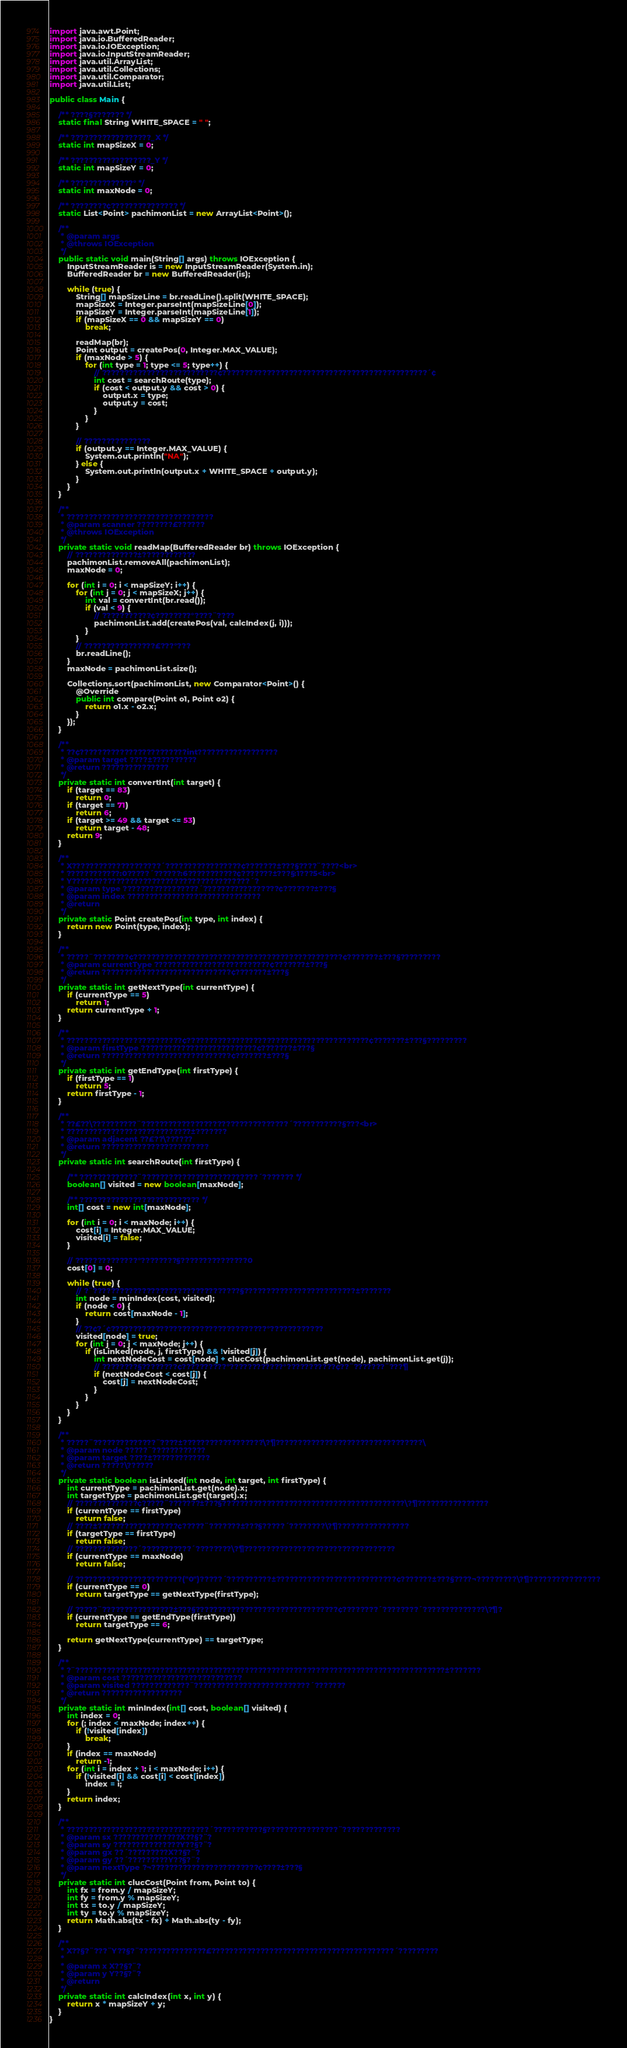Convert code to text. <code><loc_0><loc_0><loc_500><loc_500><_Java_>import java.awt.Point;
import java.io.BufferedReader;
import java.io.IOException;
import java.io.InputStreamReader;
import java.util.ArrayList;
import java.util.Collections;
import java.util.Comparator;
import java.util.List;

public class Main {

	/** ????§??????? */
	static final String WHITE_SPACE = " ";

	/** ??????????????????_X */
	static int mapSizeX = 0;

	/** ??????????????????_Y */
	static int mapSizeY = 0;

	/** ??????????????° */
	static int maxNode = 0;

	/** ????????¢??????????????? */
	static List<Point> pachimonList = new ArrayList<Point>();

	/**
	 * @param args
	 * @throws IOException
	 */
	public static void main(String[] args) throws IOException {
		InputStreamReader is = new InputStreamReader(System.in);
		BufferedReader br = new BufferedReader(is);

		while (true) {
			String[] mapSizeLine = br.readLine().split(WHITE_SPACE);
			mapSizeX = Integer.parseInt(mapSizeLine[0]);
			mapSizeY = Integer.parseInt(mapSizeLine[1]);
			if (mapSizeX == 0 && mapSizeY == 0)
				break;

			readMap(br);
			Point output = createPos(0, Integer.MAX_VALUE);
			if (maxNode > 5) {
				for (int type = 1; type <= 5; type++) {
					// ??????????????????????????¢??????????????????????????????????????????????´¢
					int cost = searchRoute(type);
					if (cost < output.y && cost > 0) {
						output.x = type;
						output.y = cost;
					}
				}
			}

			// ???????????????
			if (output.y == Integer.MAX_VALUE) {
				System.out.println("NA");
			} else {
				System.out.println(output.x + WHITE_SPACE + output.y);
			}
		}
	}

	/**
	 * ?????????????????????????????????
	 * @param scanner ????????£??????
	 * @throws IOException
	 */
	private static void readMap(BufferedReader br) throws IOException {
		// ??????????????±????????????
		pachimonList.removeAll(pachimonList);
		maxNode = 0;

		for (int i = 0; i < mapSizeY; i++) {
			for (int j = 0; j < mapSizeX; j++) {
				int val = convertInt(br.read());
				if (val < 9) {
					// ???????????¢????????°????¨????
					pachimonList.add(createPos(val, calcIndex(j, i)));
				}
			}
			// ????????????????£???°???
			br.readLine();
		}
		maxNode = pachimonList.size();

		Collections.sort(pachimonList, new Comparator<Point>() {
			@Override
			public int compare(Point o1, Point o2) {
				return o1.x - o2.x;
			}
		});
	}

	/**
	 * ??¢????????????????????????int??????????????????
	 * @param target ????±??????????
	 * @return ???????????????
	 */
	private static int convertInt(int target) {
		if (target == 83)
			return 0;
		if (target == 71)
			return 6;
		if (target >= 49 && target <= 53)
			return target - 48;
		return 9;
	}

	/**
	 * X????????????????????´?????????????????¢???????±???§????¨????<br>
	 * ????????????:0?????´??????:6???????????¢???????±???§:1???5<br>
	 * Y????????????????????????????????????????´?
	 * @param type ?????????????????´?????????????????¢???????±???§
	 * @param index ??????????????????????????????
	 * @return
	 */
	private static Point createPos(int type, int index) {
		return new Point(type, index);
	}

	/**
	 * ?????¨????????¢???????????????????????????????????????????????¢???????±???§?????????
	 * @param currentType ??????????????????????????¢???????±???§
	 * @return ?????????????????????????????¢???????±???§
	 */
	private static int getNextType(int currentType) {
		if (currentType == 5)
			return 1;
		return currentType + 1;
	}

	/**
	 * ??????????????????????????¢?????????????????????????????????????????¢???????±???§?????????
	 * @param firstType ??????????????????????????¢???????±???§
	 * @return ?????????????????????????????¢???????±???§
	 */
	private static int getEndType(int firstType) {
		if (firstType == 1)
			return 5;
		return firstType - 1;
	}

	/**
	 * ??£??\??????????¨?????????????????????????????????´???????????§???<br>
	 * ????????????????????????????±???????
	 * @param adjacent ??£??\??????
	 * @return ????????????????????????
	 */
	private static int searchRoute(int firstType) {

		/** ?????????????¨??????????????????????????´??????? */
		boolean[] visited = new boolean[maxNode];

		/** ??????????????????????????? */
		int[] cost = new int[maxNode];

		for (int i = 0; i < maxNode; i++) {
			cost[i] = Integer.MAX_VALUE;
			visited[i] = false;
		}

		// ??????????????°????????§???????????????0
		cost[0] = 0;

		while (true) {
			// ?¨?????????????????????????????????§?????????????????????????±???????
			int node = minIndex(cost, visited);
			if (node < 0) {
				return cost[maxNode - 1];
			}
			// ??¢?´¢???????????????????????????????????°????????????
			visited[node] = true;
			for (int j = 0; j < maxNode; j++) {
				if (isLinked(node, j, firstType) && !visited[j]) {
					int nextNodeCost = cost[node] + clucCost(pachimonList.get(node), pachimonList.get(j));
					// ????????§????????¢??????????°????????????°???????????¢??¨???????¨???¶
					if (nextNodeCost < cost[j]) {
						cost[j] = nextNodeCost;
					}
				}
			}
		}
	}

	/**
	 * ?????¨??????????????¨????±??????????????????\?¶?????????????????????????????????\
	 * @param node ?????¨????????????
	 * @param target ????±?????????????
	 * @return ?????\??????
	 */
	private static boolean isLinked(int node, int target, int firstType) {
		int currentType = pachimonList.get(node).x;
		int targetType = pachimonList.get(target).x;
		// ??????????????¢?????¨???????±???§?????????????????????????????????????????\?¶????????????????
		if (currentType == firstType)
			return false;
		// ????±??????????????????¢?????¨???????±???§?????´????????\?¶????????????????
		if (targetType == firstType)
			return false;
		// ??????????????´???????????´????????\?¶??????????????????????????????????
		if (currentType == maxNode)
			return false;

		// ????????????????????????("0")?????´??????????±???????????????????????????¢???????±???§????¬?????????\?¶????????????????
		if (currentType == 0)
			return targetType == getNextType(firstType);

		// ?????¨????????????????±???§????????????????????????????????¢????????´????????´??????????????\?¶?
		if (currentType == getEndType(firstType))
			return targetType == 6;

		return getNextType(currentType) == targetType;
	}

	/**
	 * ?¨???????????????????????????????????????????????????????????????????????????????????±???????
	 * @param cost ???????????????????????????
	 * @param visited ?????????????¨??????????????????????????´???????
	 * @return ??????????????????
	 */
	private static int minIndex(int[] cost, boolean[] visited) {
		int index = 0;
		for (; index < maxNode; index++) {
			if (!visited[index])
				break;
		}
		if (index == maxNode)
			return -1;
		for (int i = index + 1; i < maxNode; i++) {
			if (!visited[i] && cost[i] < cost[index])
				index = i;
		}
		return index;
	}

	/**
	 * ????????????????????????????????´???????????§????????????????¨?????????????
	 * @param sx ???????????????X??§?¨?
	 * @param sy ???????????????Y??§?¨?
	 * @param gx ??´?????????X??§?¨?
	 * @param gy ??´?????????Y??§?¨?
	 * @param nextType ?¬????????????????????????¢????±???§
	 */
	private static int clucCost(Point from, Point to) {
		int fx = from.y / mapSizeY;
		int fy = from.y % mapSizeY;
		int tx = to.y / mapSizeY;
		int ty = to.y % mapSizeY;
		return Math.abs(tx - fx) + Math.abs(ty - fy);
	}

	/**
	 * X??§?¨???¨Y??§?¨???????????????£?????????????????????????????????????????´?????????
	 *
	 * @param x X??§?¨?
	 * @param y Y??§?¨?
	 * @return
	 */
	private static int calcIndex(int x, int y) {
		return x * mapSizeY + y;
	}
}</code> 